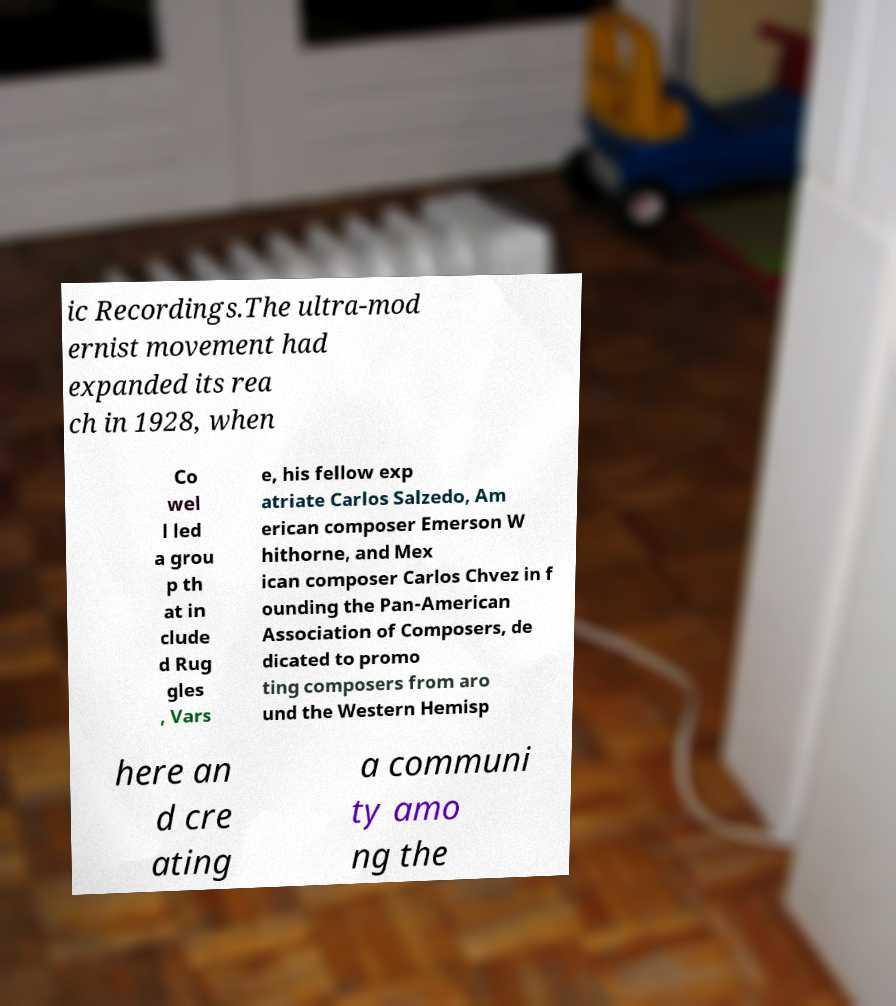There's text embedded in this image that I need extracted. Can you transcribe it verbatim? ic Recordings.The ultra-mod ernist movement had expanded its rea ch in 1928, when Co wel l led a grou p th at in clude d Rug gles , Vars e, his fellow exp atriate Carlos Salzedo, Am erican composer Emerson W hithorne, and Mex ican composer Carlos Chvez in f ounding the Pan-American Association of Composers, de dicated to promo ting composers from aro und the Western Hemisp here an d cre ating a communi ty amo ng the 